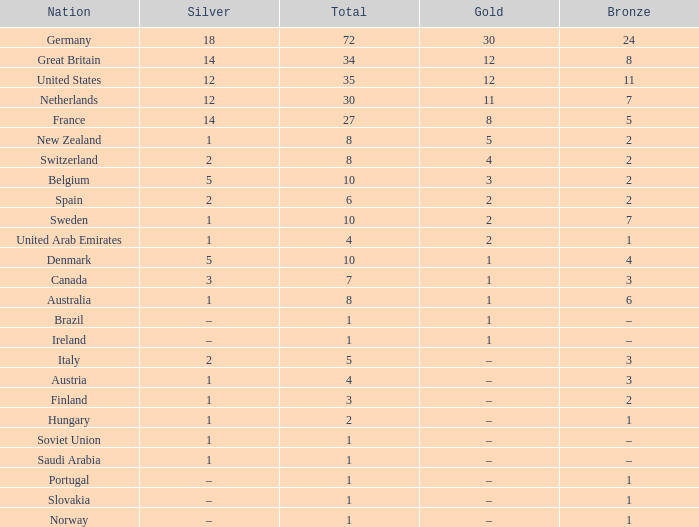What is the total number of Total, when Silver is 1, and when Bronze is 7? 1.0. Can you parse all the data within this table? {'header': ['Nation', 'Silver', 'Total', 'Gold', 'Bronze'], 'rows': [['Germany', '18', '72', '30', '24'], ['Great Britain', '14', '34', '12', '8'], ['United States', '12', '35', '12', '11'], ['Netherlands', '12', '30', '11', '7'], ['France', '14', '27', '8', '5'], ['New Zealand', '1', '8', '5', '2'], ['Switzerland', '2', '8', '4', '2'], ['Belgium', '5', '10', '3', '2'], ['Spain', '2', '6', '2', '2'], ['Sweden', '1', '10', '2', '7'], ['United Arab Emirates', '1', '4', '2', '1'], ['Denmark', '5', '10', '1', '4'], ['Canada', '3', '7', '1', '3'], ['Australia', '1', '8', '1', '6'], ['Brazil', '–', '1', '1', '–'], ['Ireland', '–', '1', '1', '–'], ['Italy', '2', '5', '–', '3'], ['Austria', '1', '4', '–', '3'], ['Finland', '1', '3', '–', '2'], ['Hungary', '1', '2', '–', '1'], ['Soviet Union', '1', '1', '–', '–'], ['Saudi Arabia', '1', '1', '–', '–'], ['Portugal', '–', '1', '–', '1'], ['Slovakia', '–', '1', '–', '1'], ['Norway', '–', '1', '–', '1']]} 